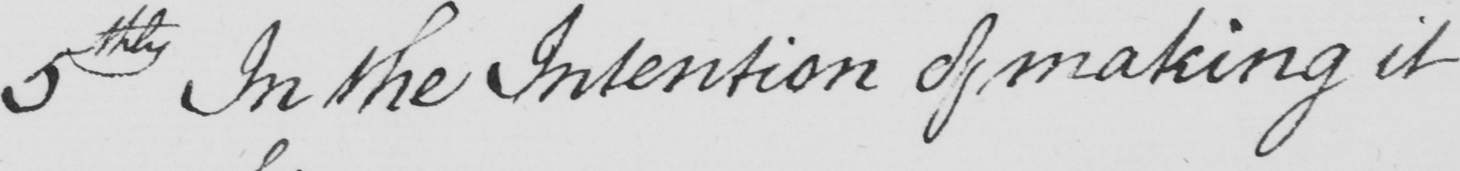What does this handwritten line say? 5th In the Intention of making it 